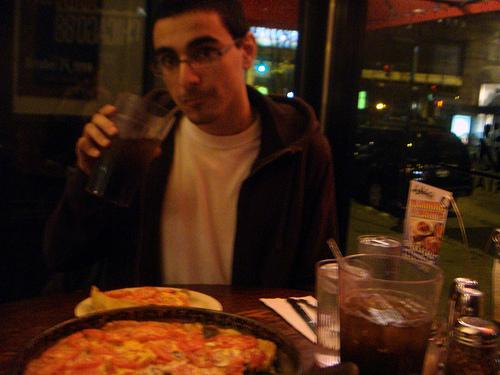Count the total number of whole and sliced tomatoes on the pizza. There are sliced tomatoes on the pizza; however, it is impossible to determine the total number based on the given information. List three objects placed on the table. A water glass, a slice of pizza on a white plate, and silverware on a white napkin. Briefly describe the image's atmosphere. The image conveys a casual dining atmosphere with a man enjoying his meal, surrounded by various food items and drinks. Identify the food item on a white plate and describe its main ingredient. A slice of pizza is on a white plate, and its main ingredient is tomato sauce and cheese. What is the man wearing and what is he holding? The man is wearing a white t-shirt, eye glasses, and has facial hair. He is holding a clear cup with a drink. How many glasses are on the table near the man? There are three glasses: one full glass of water left of man, one full glass in front of man, and a glass of soda in the foreground. What sentiment do you perceive from the image? A relaxed and enjoyable sentiment, as the man seems to be having a good time while dining in a casual environment with various food items and drinks. Provide a reasoning for the presence of the spice shaker in the bottom left corner. The spice shaker, likely containing red pepper flakes, is placed on the table to allow guests to add extra seasoning to their food according to their taste preference. What type of vehicle is parked outside the restaurant? An SUV truck is parked outside the restaurant. Assess the variety of food items in the image. The variety is moderate, mainly consisting of pizza, tomatoes, and toppings, but also includes beverages and condiments. Draft a brief description of the location where this image likely took place. A casual dining pizzeria, featuring comfortable seating and an outdoor view Is there a car parked outside instead of an SUV truck? There is actually an SUV truck parked outside, not a car. Do you see a plate of salad in front of the man? There is actually a plate of pizza in front of the man, not a plate of salad. Can you see an empty glass of water to the right of the man? There are two full glasses of water near the man, but none of them are empty and one is to his left, and the other is in front of him. What type of vehicle can you spot outside of the restaurant window? SUV truck parked outside Create a sentence describing the scene in the image, incorporating elements such as the man, glass, pizza, and restaurant. In the cozy restaurant, a man wearing glasses and a white t-shirt savors his deep dish pizza, sipping drinks as he admires the outside view. Rewrite the following caption in a more creative and engaging way: "Whole pizza in pizza pan." A scrumptious deep-dish pizza awaits in a sizzling hot pan Identify and describe the objects on the table closely related to the man. A slice of pizza on a white plate, two glasses of water, and a glass of soda in the foreground What type of drink is in the foreground, both in front of the man and to his left? Water and soda Is there any caption explaining the small sign outside the restaurant? Yes, "small sign about restaurant" Is the man wearing a red tshirt? The man is actually wearing a white tshirt, not a red one. Identify a caption for the scene in the restaurant focusing on the man's appearance. Bearded man in glasses enjoys pizza at a laid-back restaurant What are the toppings on the deep dish pizza featured in the image? Sliced tomatoes Count how many types of shakers are present on the table. Three shakers - pepper flakes, salt, and pepper Is the man holding a plate of pizza in his hand? The man is actually holding a drink in his hand, not a plate of pizza. What is the man holding in his hand? A drink Describe the variety of beverages seen in the image. Water glasses on the table and a glass of soda in the foreground Which type of pizza is visible in the image? Deep dish pizza with sliced tomatoes Is there any utensil visible and, if so, where is it placed? Yes, silverware on a white napkin What items are visible in the bottom left corner of the image? A spice shaker and salt and pepper shaker Does the man in the image have facial hair and what type of shirt he is wearing? Yes, he has facial hair and is wearing a white t-shirt What is the color of the man's shirt and is he wearing any eyewear? White shirt and wearing eye glasses What is the common activity happening in the given image in a restaurant setting? A man enjoying a meal (pizza and drinks) Is there a green pepper flakes jar on the table? The jar is actually filled with red pepper flakes, not green pepper flakes. 